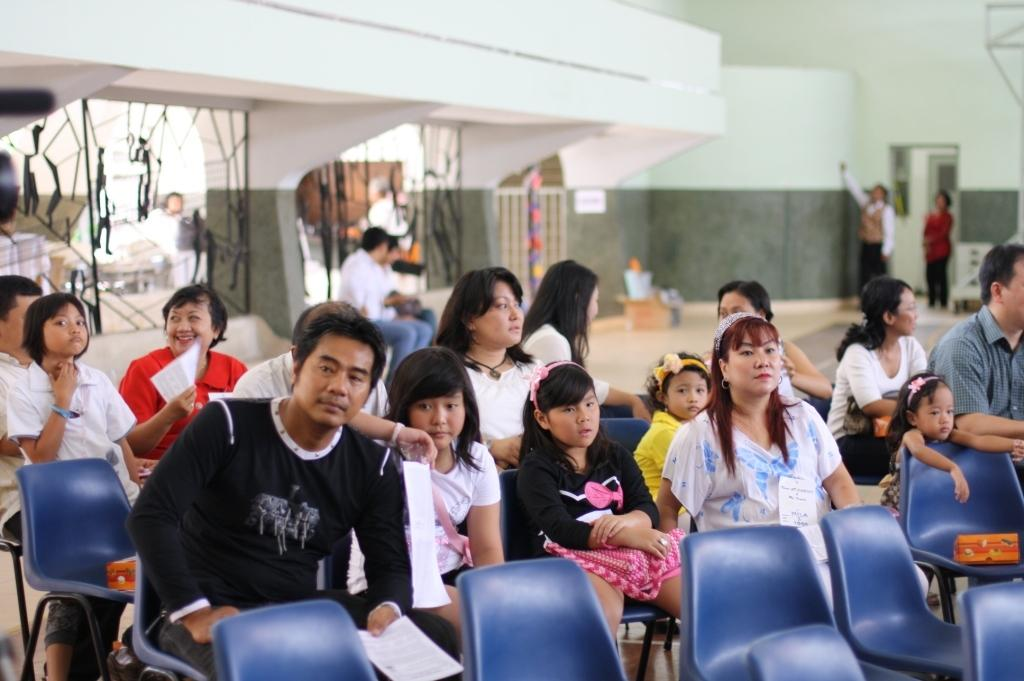Where was the image taken? The image was taken indoors. What furniture can be seen in the image? There are multiple chairs in the image. What are the people in the image doing? People are sitting on the chairs. How many persons are on the right side of the image? There are two persons on the right side of the image. What can be seen behind the two persons? There is an opening visible behind the two persons. What type of underwear is visible on the person sitting on the left chair? There is no underwear visible in the image, as the people are fully clothed while sitting on the chairs. How many ears can be counted on the persons in the image? The number of ears cannot be determined from the image, as it only provides a partial view of the people's faces. 